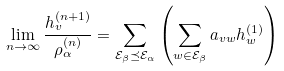Convert formula to latex. <formula><loc_0><loc_0><loc_500><loc_500>\lim _ { n \rightarrow \infty } \frac { h _ { v } ^ { ( n + 1 ) } } { \rho _ { \alpha } ^ { ( n ) } } = \sum _ { \mathcal { E } _ { \beta } \preceq \mathcal { E } _ { \alpha } } \left ( \sum _ { w \in \mathcal { E } _ { \beta } } a _ { v w } h _ { w } ^ { ( 1 ) } \right )</formula> 